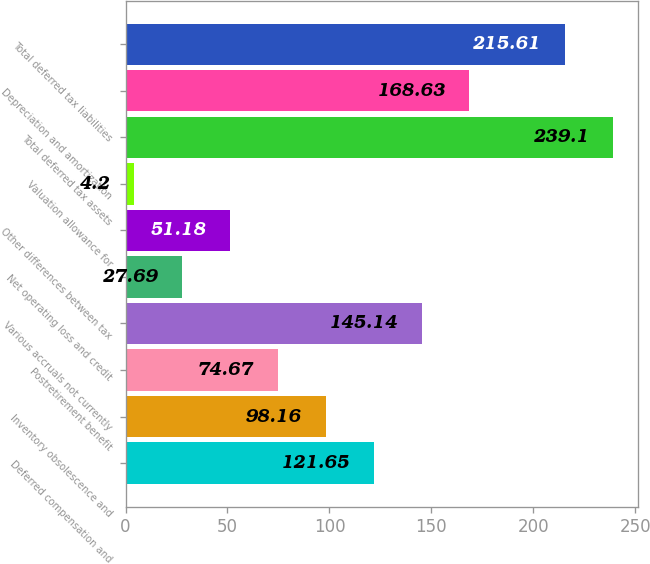<chart> <loc_0><loc_0><loc_500><loc_500><bar_chart><fcel>Deferred compensation and<fcel>Inventory obsolescence and<fcel>Postretirement benefit<fcel>Various accruals not currently<fcel>Net operating loss and credit<fcel>Other differences between tax<fcel>Valuation allowance for<fcel>Total deferred tax assets<fcel>Depreciation and amortization<fcel>Total deferred tax liabilities<nl><fcel>121.65<fcel>98.16<fcel>74.67<fcel>145.14<fcel>27.69<fcel>51.18<fcel>4.2<fcel>239.1<fcel>168.63<fcel>215.61<nl></chart> 